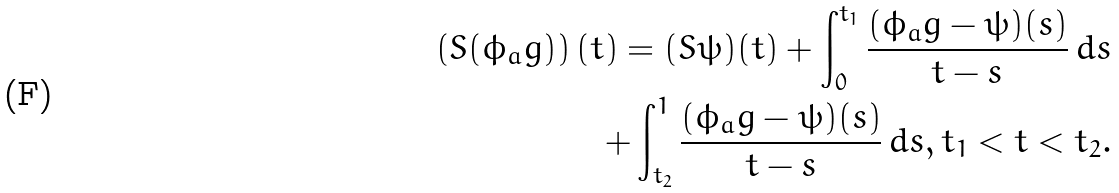Convert formula to latex. <formula><loc_0><loc_0><loc_500><loc_500>\left ( S ( \phi _ { a } g ) \right ) ( t ) = ( S \psi ) ( t ) + \int _ { 0 } ^ { t _ { 1 } } \frac { ( \phi _ { a } g - \psi ) ( s ) } { t - s } \, d s \\ + \int _ { t _ { 2 } } ^ { 1 } \frac { ( \phi _ { a } g - \psi ) ( s ) } { t - s } \, d s , t _ { 1 } < t < t _ { 2 } .</formula> 